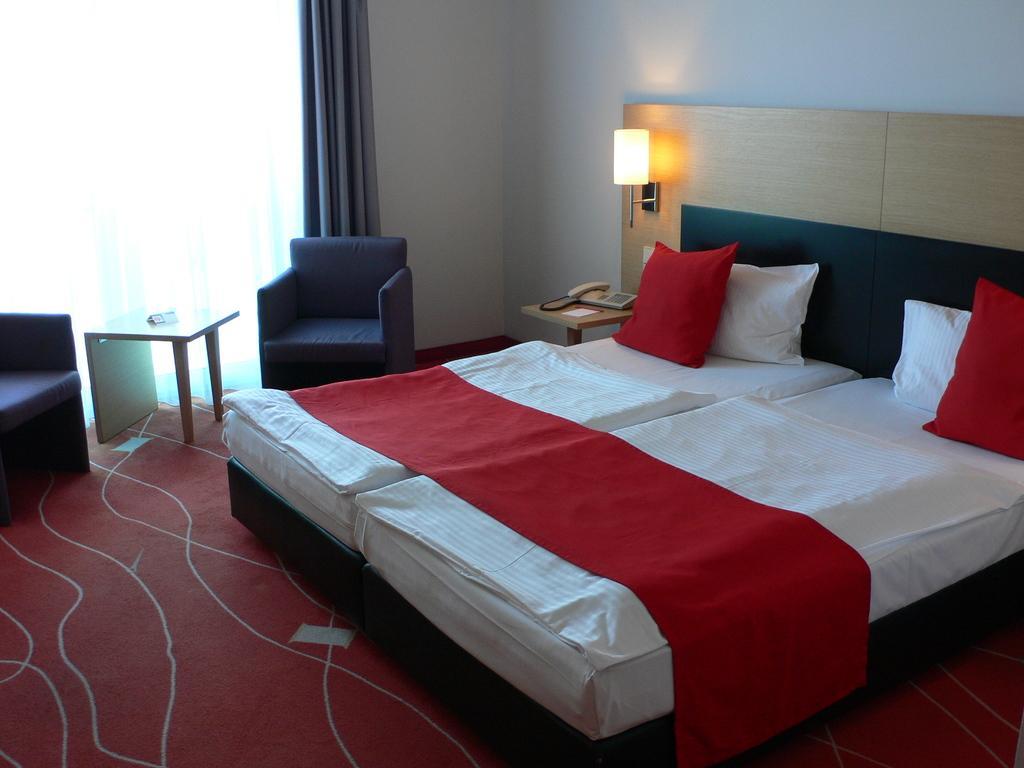Please provide a concise description of this image. It is a bedroom and there is a bed, beside the bed there is a lamp and a telephone. In the background there is a wall and beside the wall there is a curtain and in front of the curtain there are two to sofas and in between the sofas there is a stool and behind them there is a window. 